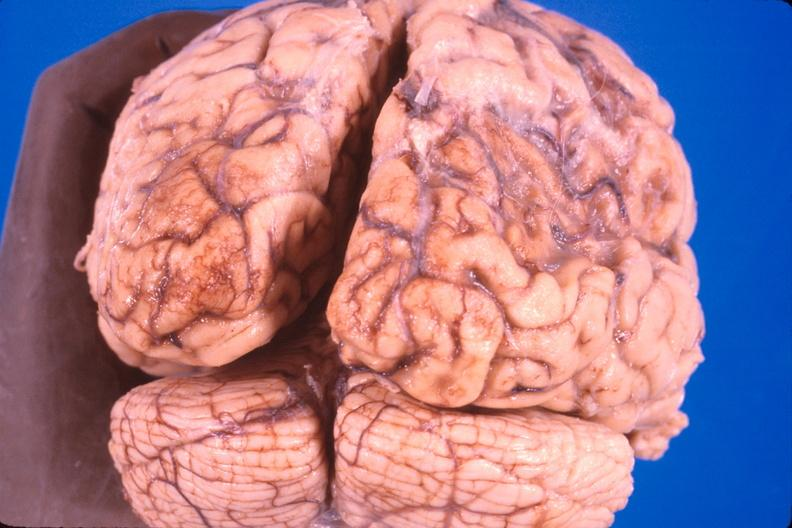what is present?
Answer the question using a single word or phrase. Nervous 